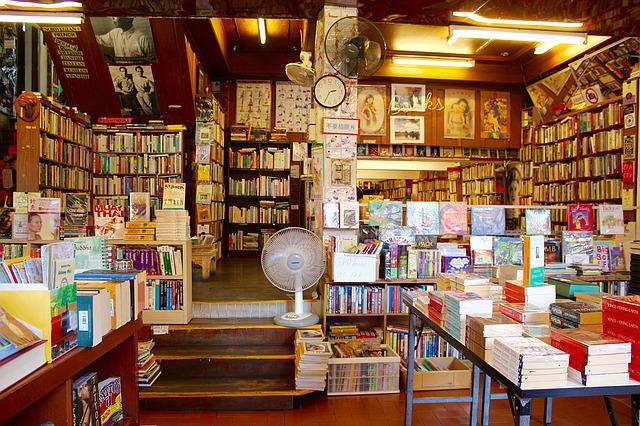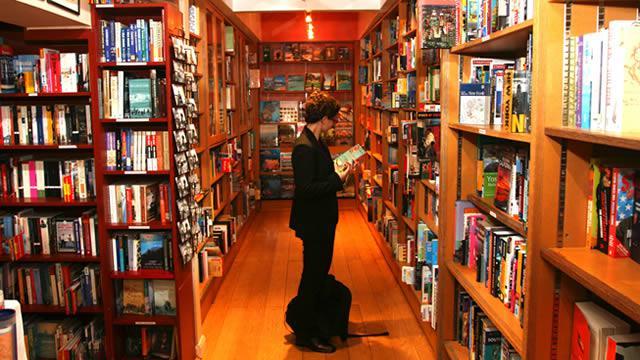The first image is the image on the left, the second image is the image on the right. For the images shown, is this caption "At least one person is standing in the aisle of a bookstore." true? Answer yes or no. Yes. The first image is the image on the left, the second image is the image on the right. Evaluate the accuracy of this statement regarding the images: "Someone dressed all in black is in the center aisle of a bookstore.". Is it true? Answer yes or no. Yes. The first image is the image on the left, the second image is the image on the right. Examine the images to the left and right. Is the description "A back-turned person wearing something pinkish stands in the aisle at the very center of the bookstore, with tall shelves surrounding them." accurate? Answer yes or no. No. The first image is the image on the left, the second image is the image on the right. For the images displayed, is the sentence "there are at least three people in the image on the right" factually correct? Answer yes or no. No. 